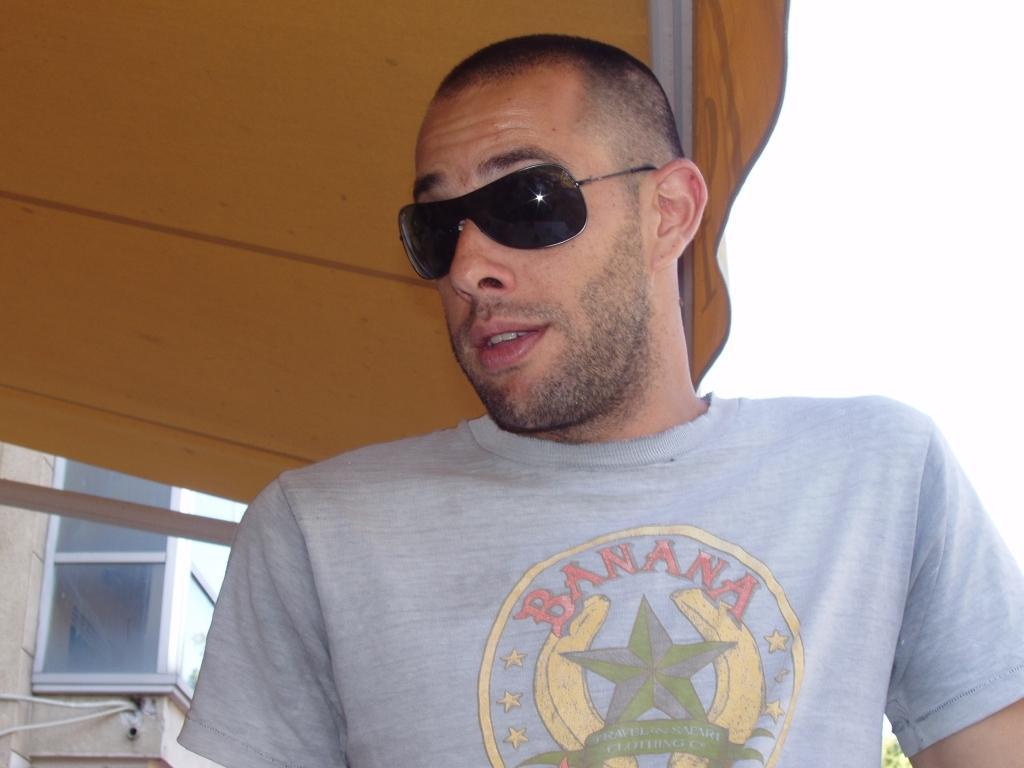Can you describe this image briefly? In this picture we can see a man, he wore goggles and a t-shirt, in the background there is a glass window, we can see a tent here. 